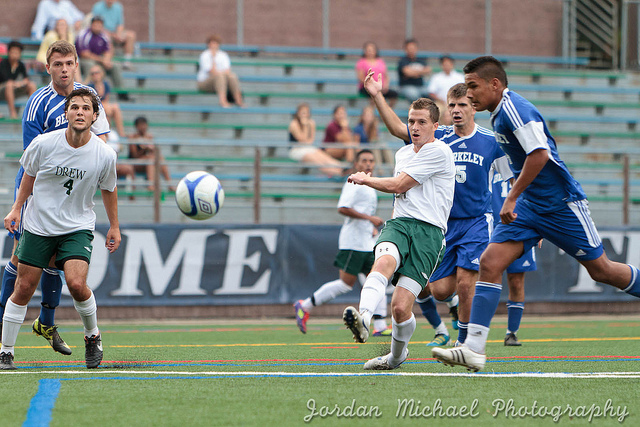Identify and read out the text in this image. DREW 4 ME 5 PHOTOGRAPHY michael JORDAN BE 